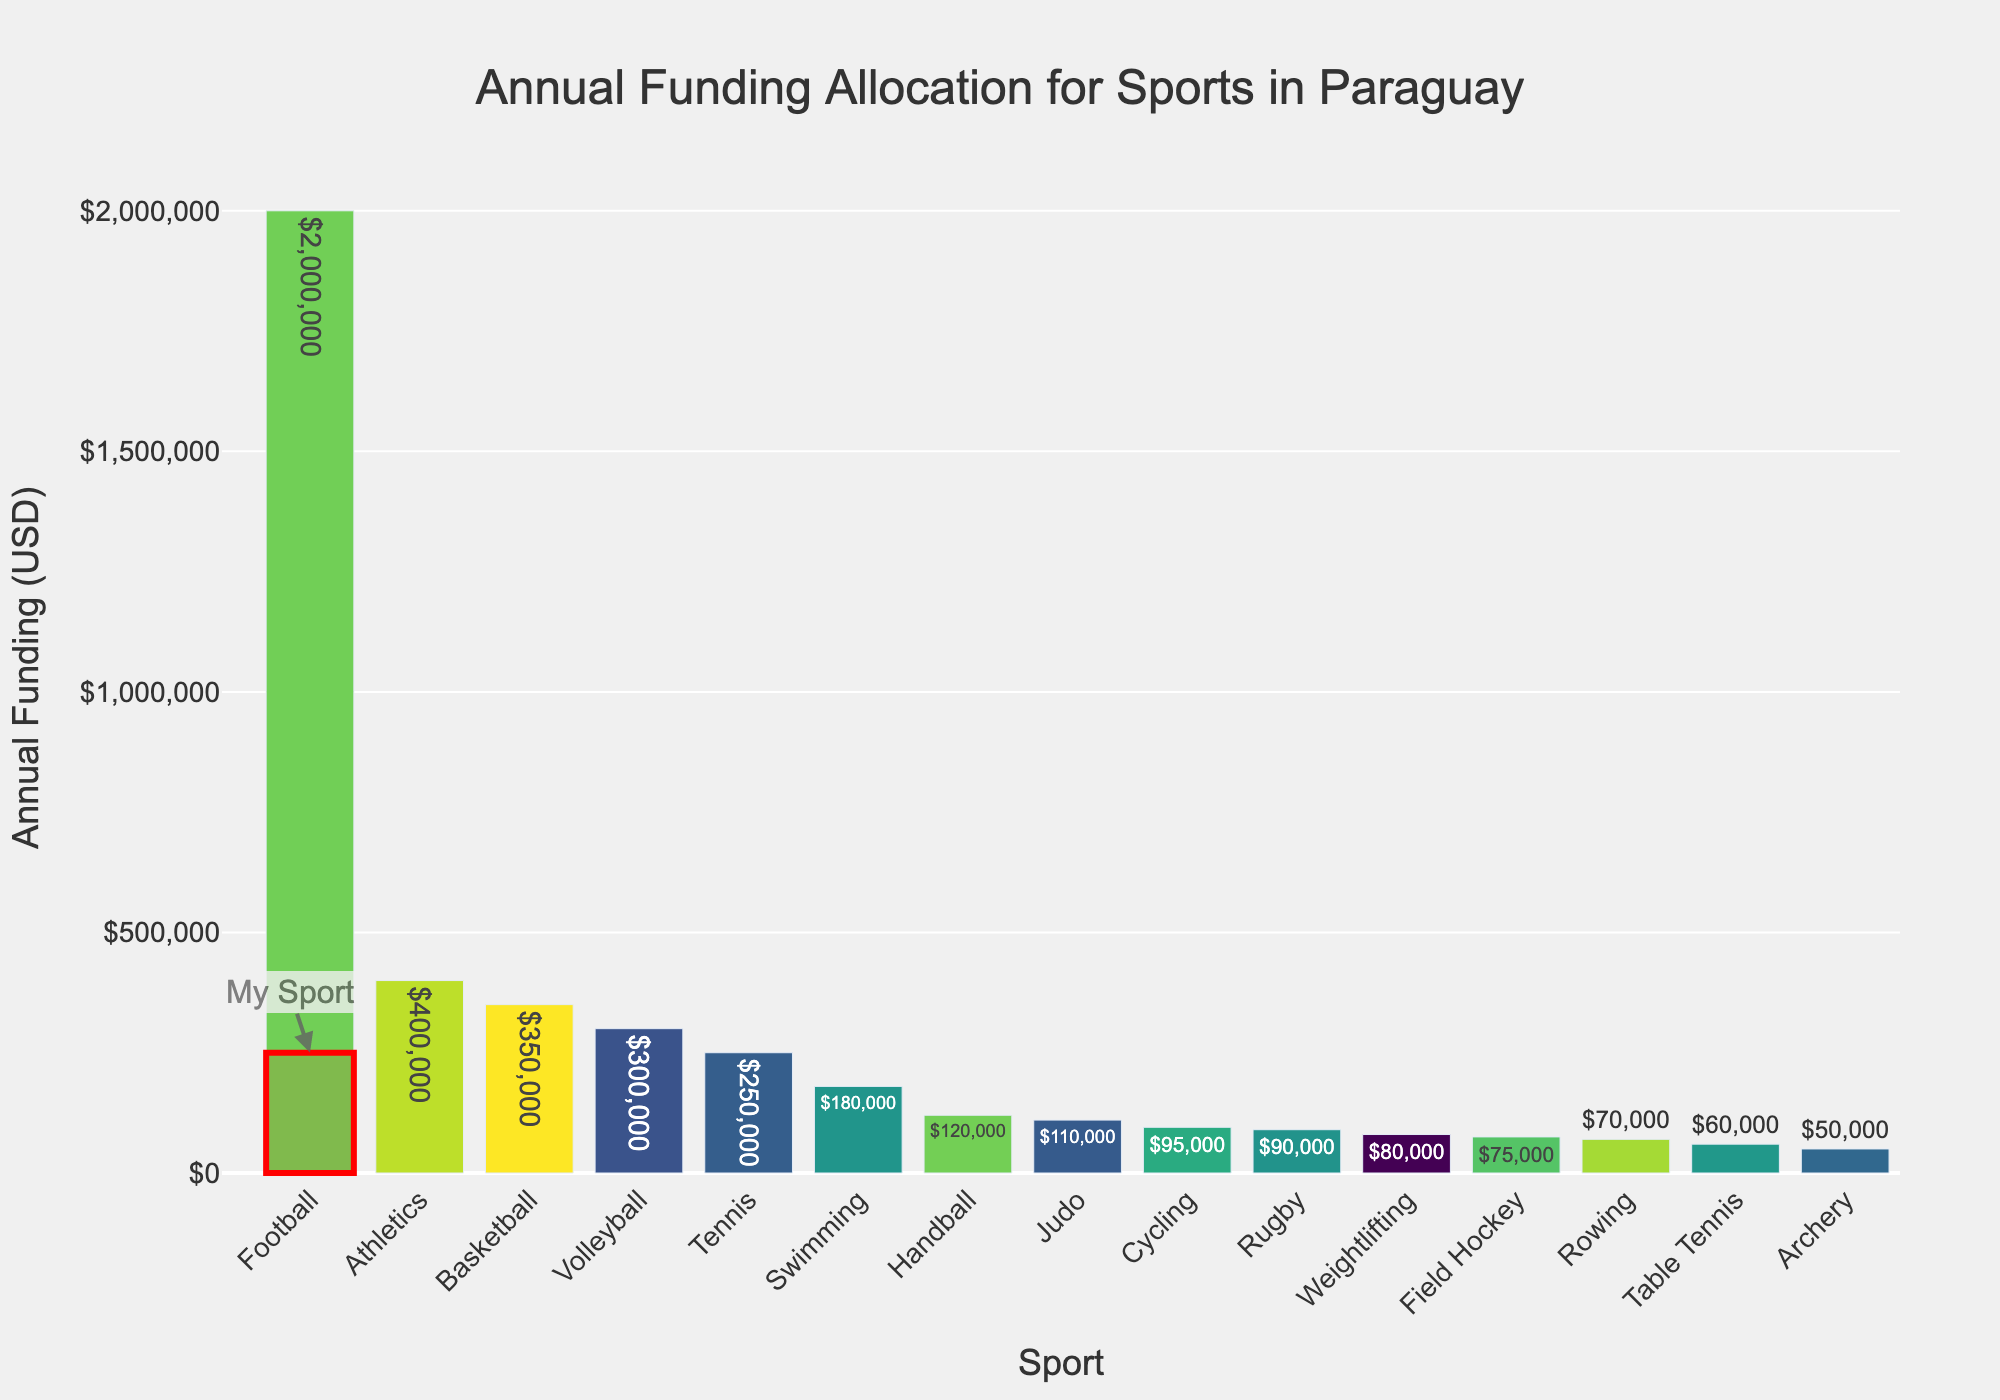Which sport receives the highest annual funding? The bar representing Football is the tallest in the chart, indicating it receives the most funding.
Answer: Football How much funding is allocated to Tennis? The bar for Tennis is highlighted prominently, and the tooltip shows the exact amount.
Answer: $250,000 Which sport has the lowest funding allocation, and what is the amount? The bar for Table Tennis is the shortest, indicating it has the lowest funding. The tooltip confirms the amount.
Answer: Table Tennis, $60,000 Compare the funding for Basketball and Volleyball. Which one receives more, and by how much? The bar for Basketball is taller than that for Volleyball. From the tooltip, Basketball receives $350,000 and Volleyball receives $300,000. The difference is $50,000.
Answer: Basketball, $50,000 What is the total funding allocated to Football and Athletics combined? Football receives $2,000,000 and Athletics receives $400,000. The sum is $2,000,000 + $400,000.
Answer: $2,400,000 Which sport has funding closest to $100,000? The bars around the $100,000 mark are for Judo, Rugby, and Weightlifting. Judo receives $110,000, Rugby receives $90,000, and Weightlifting receives $80,000. The closest to $100,000 is Rugby.
Answer: Rugby Rank the top three funded sports. The tallest three bars represent Football, Athletics, and Basketball, based on their heights.
Answer: Football, Athletics, Basketball How does the funding for Tennis compare to Swimming? The bar for Tennis is taller than that for Swimming. From the tooltip, Tennis receives $250,000 and Swimming receives $180,000.
Answer: Tennis receives more What is the average funding allocation for all sports? Sum of all the funding amounts divided by the number of sports. The total funding is $250,000 + $2,000,000 + $350,000 + $300,000 + $400,000 + $180,000 + $120,000 + $90,000 + $75,000 + $60,000 + $50,000 + $110,000 + $80,000 + $95,000 + $70,000 = $4,230,000. There are 15 sports. $4,230,000 / 15.
Answer: $282,000 